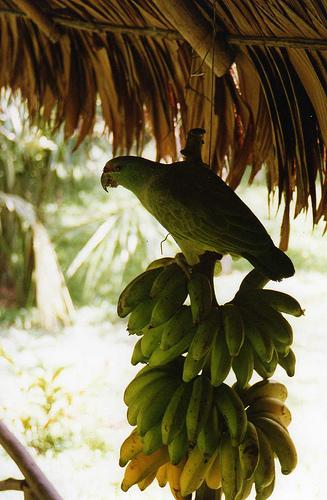Pick an iconic scene from the image for a decorative mural. A vibrant green macaw perching proudly on a bunch of colorful hanging bananas, surrounded by lush tropical elements like dried leaves and bamboo. What type of bird can be found in the image and what is it doing? A green parrot, possibly a macaw, is perching on a bunch of bananas. Pick a short and catchy headline for this image as a poster for a tropical holiday resort. "Paradise awaits: where birds and bananas unite!" For a trivia game, ask the participants which fruit is being focused on and what are its different states. Yellow ripe bananas and unripe green bananas. Select a short caption for this image for an advertisement promoting tropical fruits. "Experience the tropical taste! Bananas and parrots approve!" If you were about to create a painting based on this image, what are the key elements you would include? I would include a green parrot perching on a bunch of green and yellow bananas, with a background made of dried leaves. Mention the position and main features of the parrot in the image. The parrot is on top of the bananas, with noticeable green feathers and a visible beak and eye. Write a paragraph describing the scene in the image, incorporating details from various descriptions. In the bright, tropical setting, a vibrant green parrot, possibly a macaw, is perched atop a bunch of hanging yellow and green bananas. The bird's vibrant green feathers, beak, and eye are visible, with its foot resting on the bananas. Adding to the exotic ambiance, the setting also features a ceiling made of dried leaves and a piece of bamboo. Identify the primary object and its colors in the image. A green tropical bird, possibly a macaw, is perching on a bunch of yellow and green bananas. Imagine you are writing a children's book. Describe this scene as a part of the story. In the beautiful jungle, there was a curious green parrot exploring the area. He spotted a big bunch of yellow and green bananas hanging high up, and he decided to perch on them to take a closer look. The colorful bird seemed to be enjoying his new fruity playground under the dried leaf ceiling. 